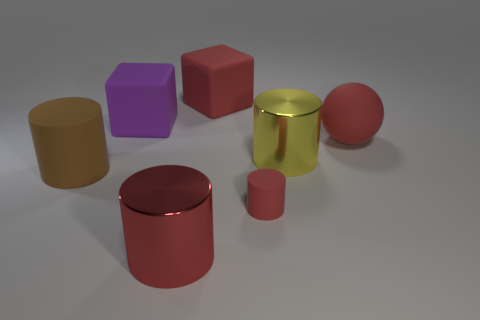There is a big block on the right side of the red metallic cylinder that is in front of the small red cylinder; what number of matte cubes are in front of it? In front of the red metallic cylinder, there appears to be just one matte cube, specifically the purple one, positioned on the right side from our perspective. 